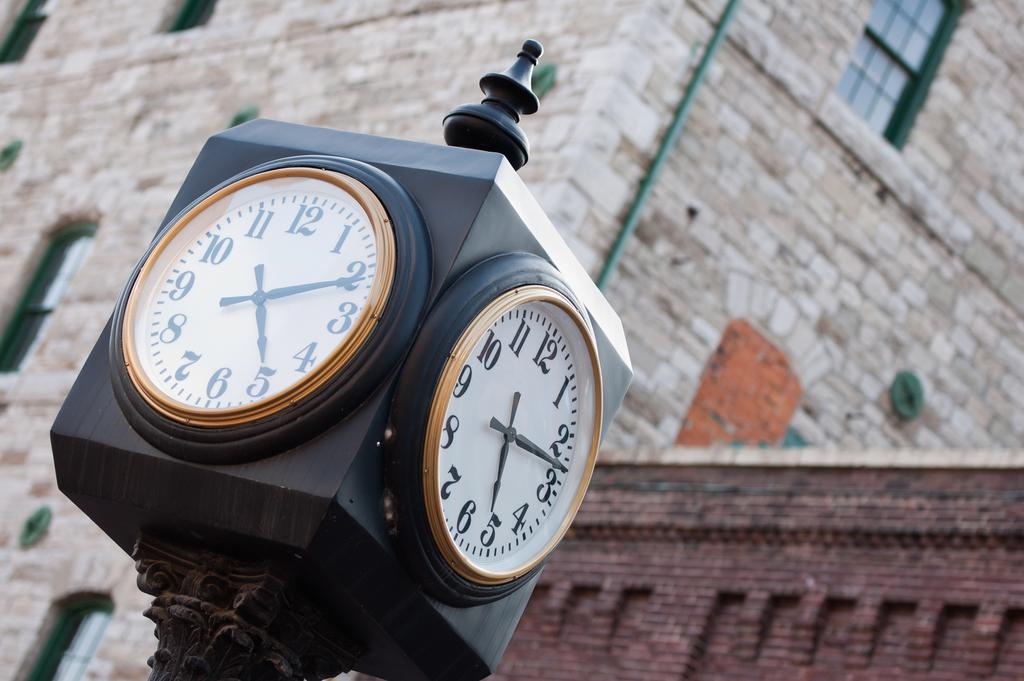<image>
Describe the image concisely. A large clock that is displaying the time of 5:11 